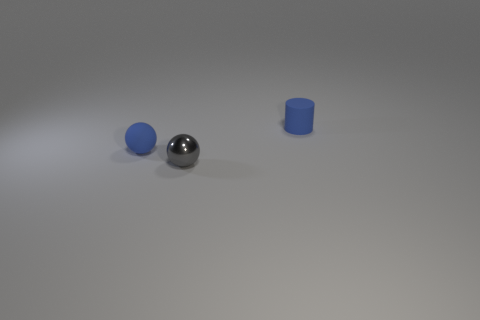Can you describe the shapes and colors of the objects in the image? Certainly! The image features three distinct objects: a small gray block that appears to be perfectly cubical, a tiny blue ball, and a medium-sized blue cylinder. They are all placed on a flat surface with a neutral tone that provides contrast to the objects. 